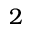Convert formula to latex. <formula><loc_0><loc_0><loc_500><loc_500>2</formula> 